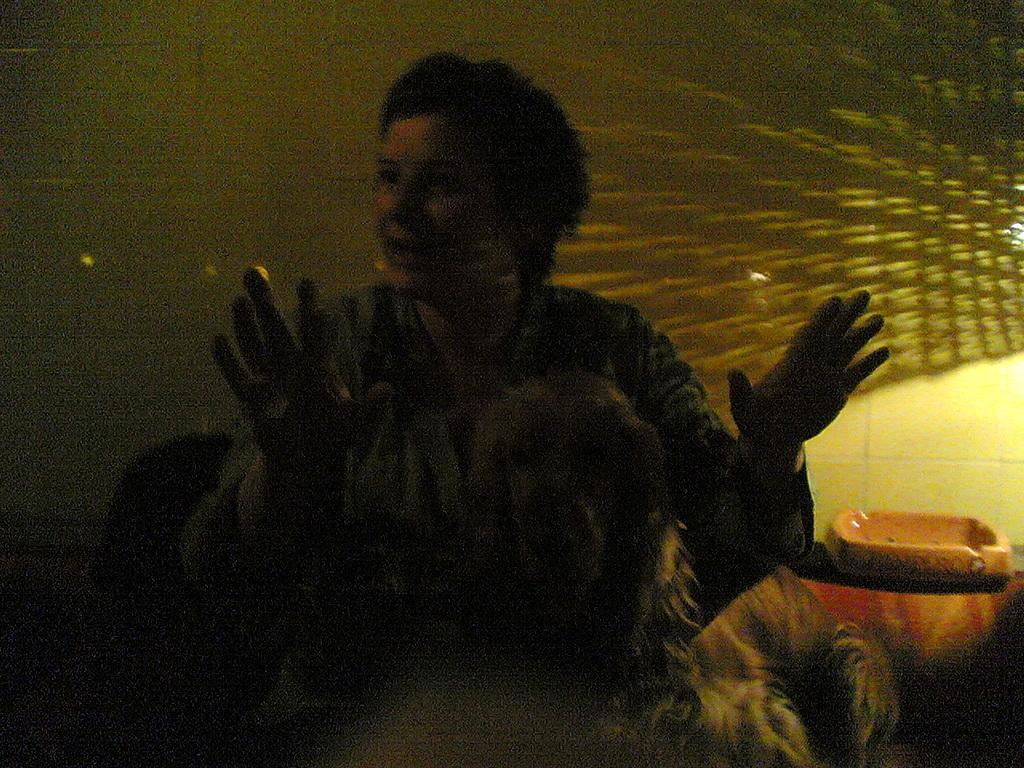What is the woman in the image doing? The woman is sitting on a chair in the image. What is in the woman's lap? The woman has a dog in her lap. What can be seen behind the woman? There is a wall visible in the background of the image. How many babies are present in the image? There are no babies present in the image. What type of office does the woman work in? The image does not show an office setting, so it cannot be determined where the woman works. 